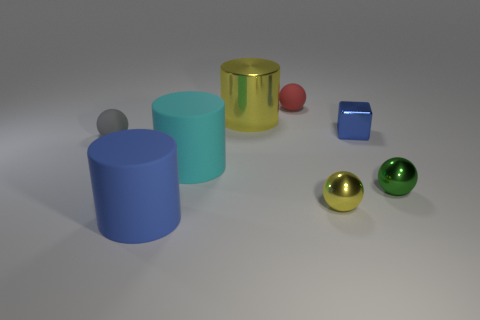What is the material of the yellow ball that is the same size as the blue metal object? metal 